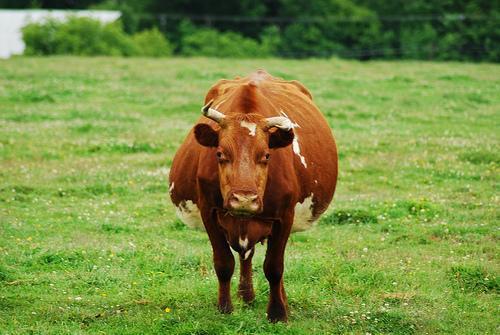How many animals are visible?
Give a very brief answer. 1. 